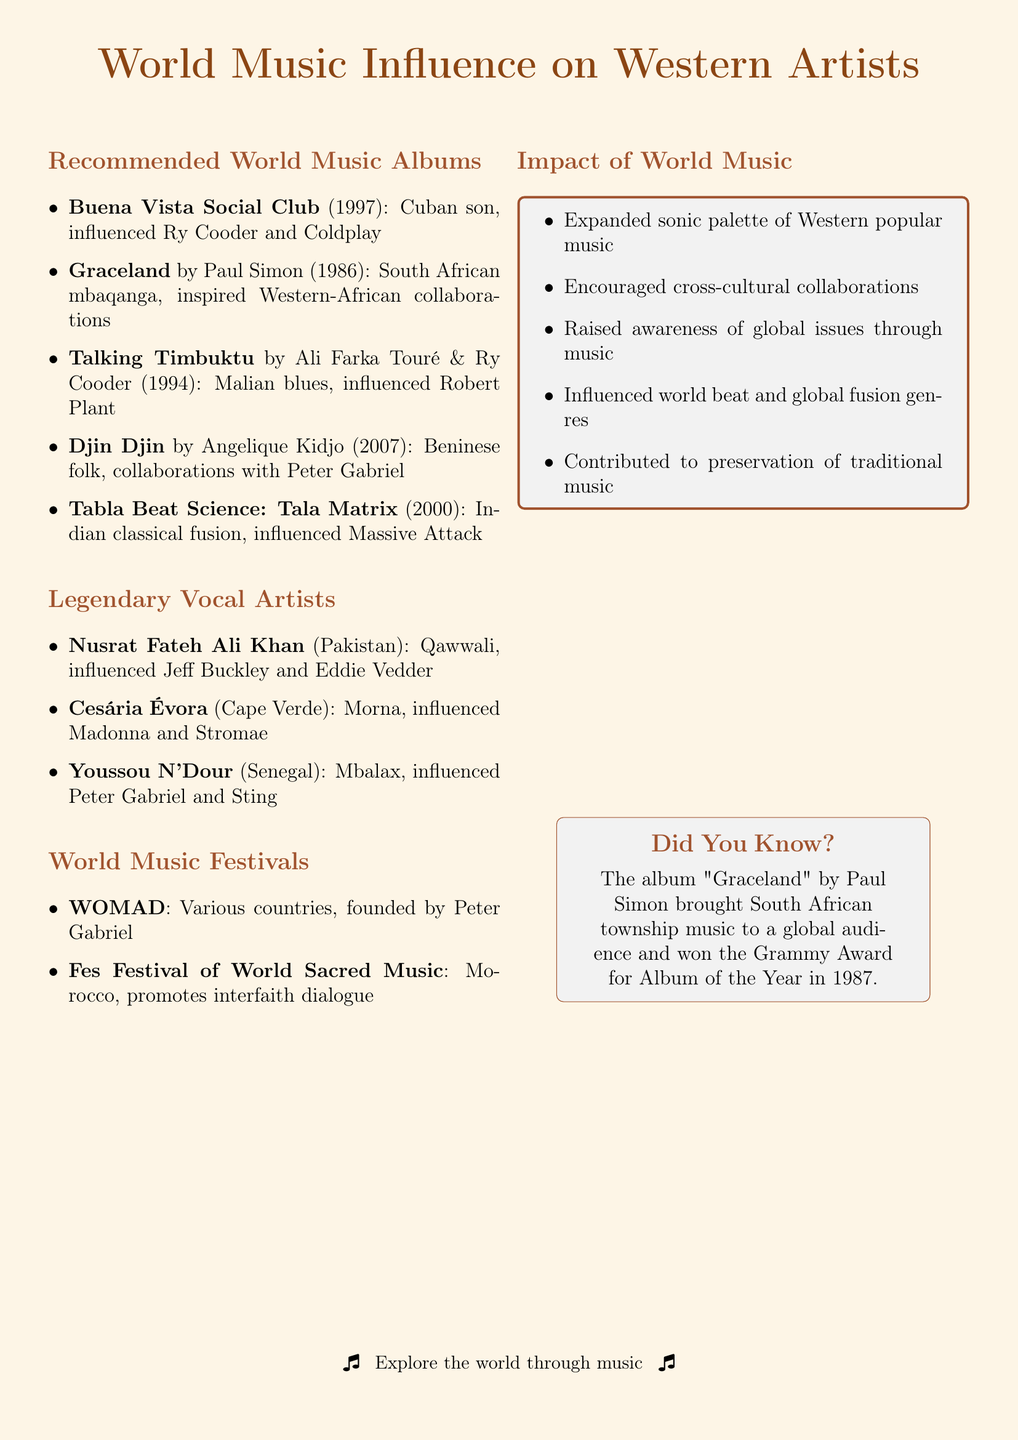What is the title of Paul Simon's album? The document lists "Graceland" as the title of Paul Simon's album.
Answer: Graceland Which genre does the album "Djin Djin" belong to? The genre of "Djin Djin" is noted as Beninese folk in the document.
Answer: Beninese folk What year was "Buena Vista Social Club" released? The document states that "Buena Vista Social Club" was released in 1997.
Answer: 1997 Who are the artists that influenced by Nusrat Fateh Ali Khan? The document lists Jeff Buckley, Peter Gabriel, and Eddie Vedder as influenced by Nusrat Fateh Ali Khan.
Answer: Jeff Buckley, Peter Gabriel, Eddie Vedder Which festival was founded by Peter Gabriel? The document mentions that WOMAD was founded by Peter Gabriel.
Answer: WOMAD What music genre did "Talking Timbuktu" represent? "Talking Timbuktu" is categorized as Malian blues in the document.
Answer: Malian blues What is one impact of world music noted in the document? The document mentions that world music has expanded the sonic palette of Western popular music.
Answer: Expanded sonic palette Name a notable track from the album "Tabla Beat Science: Tala Matrix". The notable track from the album "Tabla Beat Science: Tala Matrix" is stated as "Palmistry".
Answer: Palmistry What is the significant album of Cesária Évora? The document identifies "Miss Perfumado" as the significant album of Cesária Évora.
Answer: Miss Perfumado 